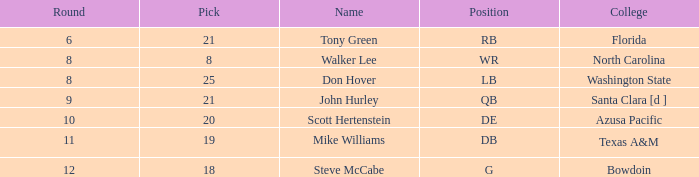Which university has a selection below 25, a total higher than 159, a round under 10, and a wide receiver as the position? North Carolina. 